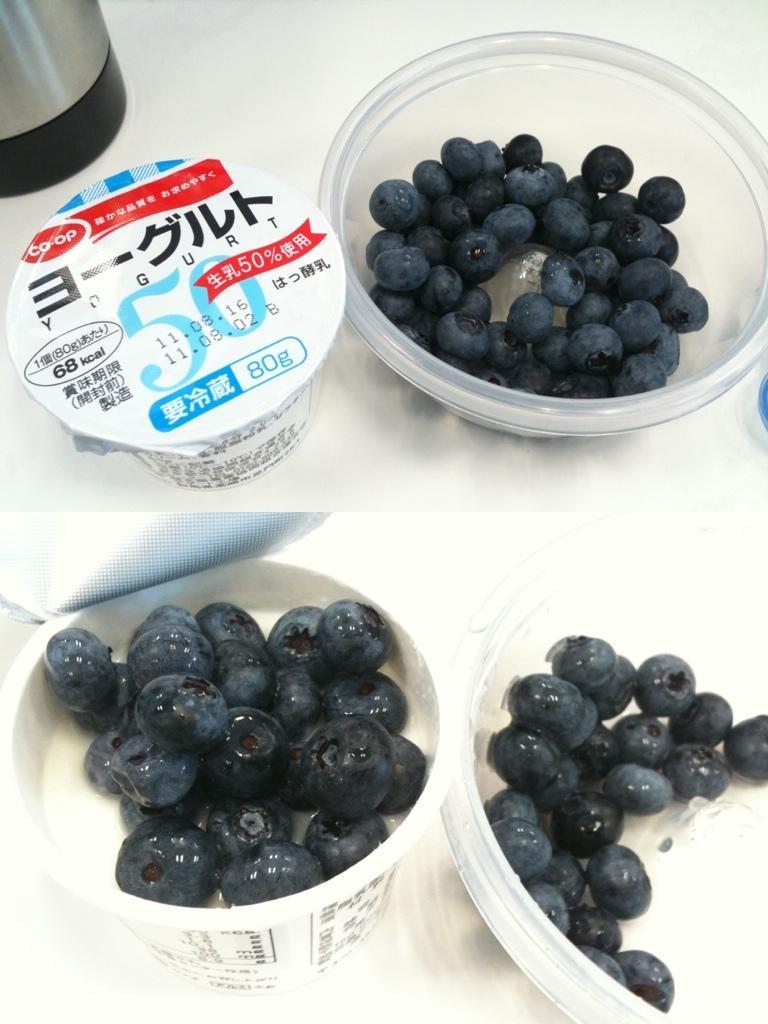Please provide a concise description of this image. This picture is a collage. At the bottom there are blueberries and cups. At the top there are cups and blueberries. 